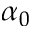<formula> <loc_0><loc_0><loc_500><loc_500>\alpha _ { 0 }</formula> 